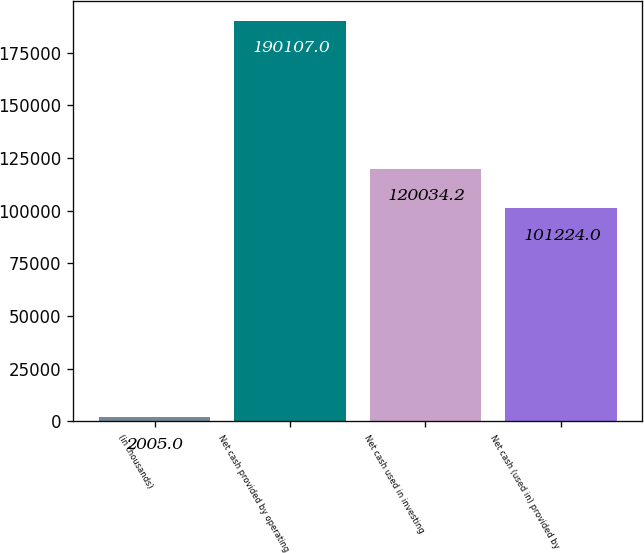Convert chart. <chart><loc_0><loc_0><loc_500><loc_500><bar_chart><fcel>(in thousands)<fcel>Net cash provided by operating<fcel>Net cash used in investing<fcel>Net cash (used in) provided by<nl><fcel>2005<fcel>190107<fcel>120034<fcel>101224<nl></chart> 